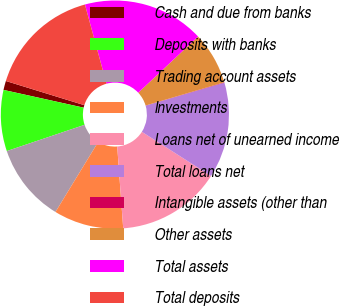<chart> <loc_0><loc_0><loc_500><loc_500><pie_chart><fcel>Cash and due from banks<fcel>Deposits with banks<fcel>Trading account assets<fcel>Investments<fcel>Loans net of unearned income<fcel>Total loans net<fcel>Intangible assets (other than<fcel>Other assets<fcel>Total assets<fcel>Total deposits<nl><fcel>1.29%<fcel>8.65%<fcel>11.1%<fcel>9.88%<fcel>14.79%<fcel>13.56%<fcel>0.06%<fcel>7.42%<fcel>17.24%<fcel>16.01%<nl></chart> 